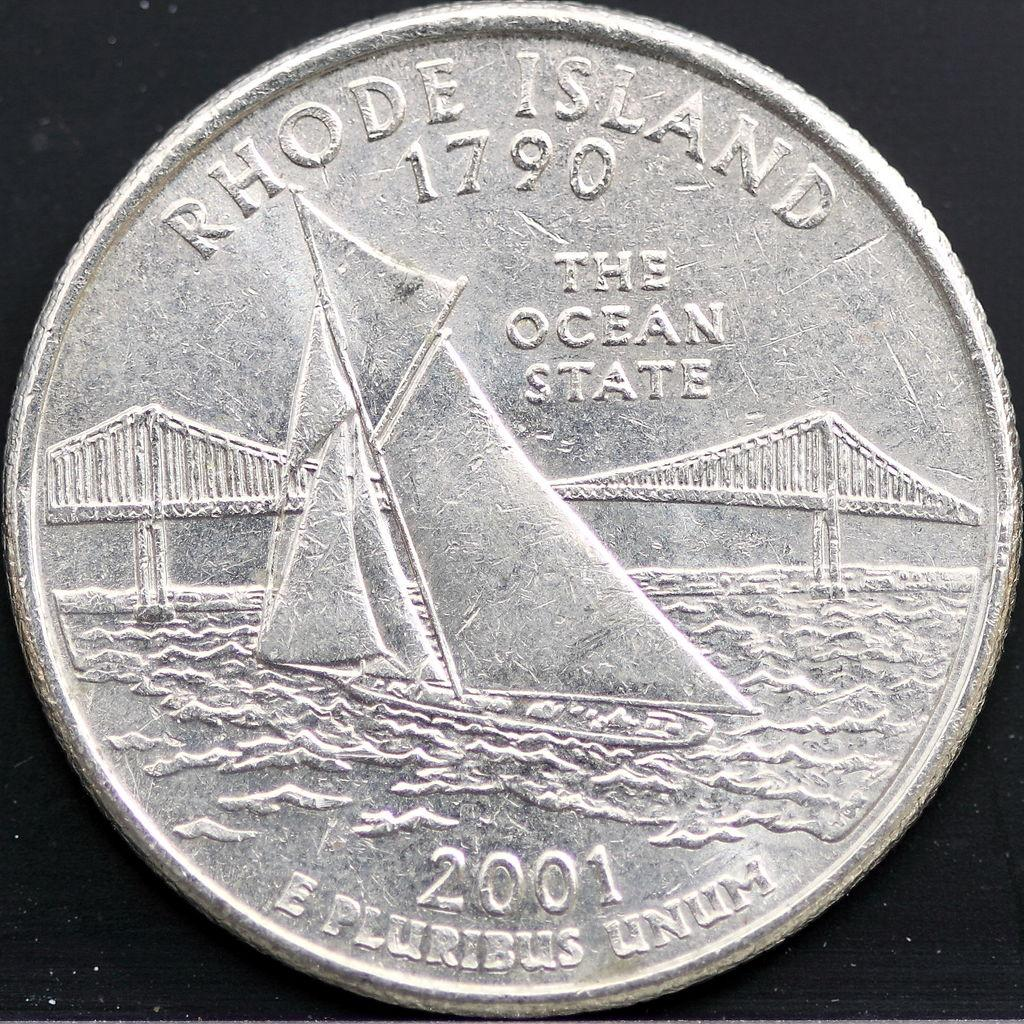<image>
Describe the image concisely. The back of a 2001 quarter features a bridge and a sailboat. 